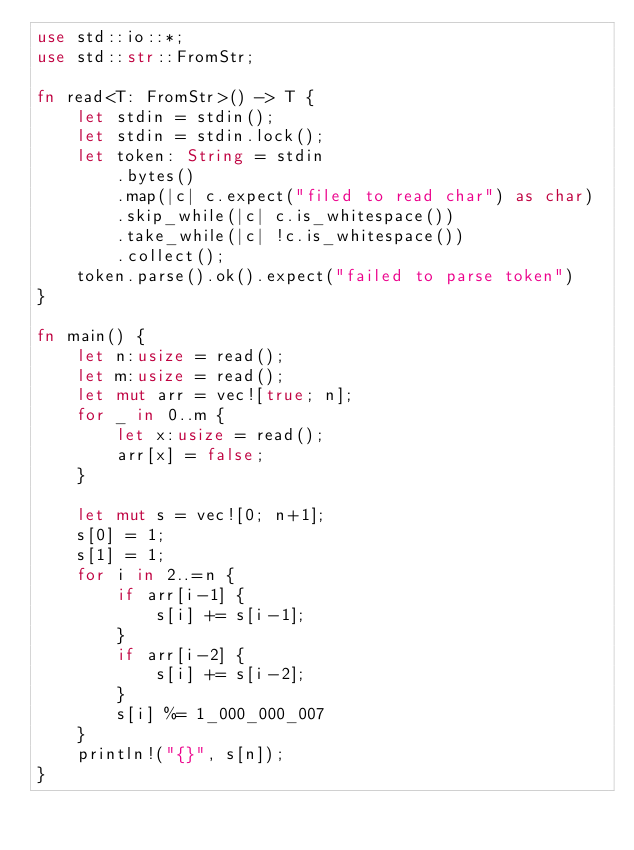<code> <loc_0><loc_0><loc_500><loc_500><_Rust_>use std::io::*;
use std::str::FromStr;

fn read<T: FromStr>() -> T {
    let stdin = stdin();
    let stdin = stdin.lock();
    let token: String = stdin
        .bytes()
        .map(|c| c.expect("filed to read char") as char)
        .skip_while(|c| c.is_whitespace())
        .take_while(|c| !c.is_whitespace())
        .collect();
    token.parse().ok().expect("failed to parse token")
}

fn main() {
    let n:usize = read();
    let m:usize = read();
    let mut arr = vec![true; n];
    for _ in 0..m {
        let x:usize = read();
        arr[x] = false;
    }

    let mut s = vec![0; n+1];
    s[0] = 1;
    s[1] = 1;
    for i in 2..=n {
        if arr[i-1] {
            s[i] += s[i-1];
        }
        if arr[i-2] {
            s[i] += s[i-2];
        }
        s[i] %= 1_000_000_007
    }
    println!("{}", s[n]);
}</code> 